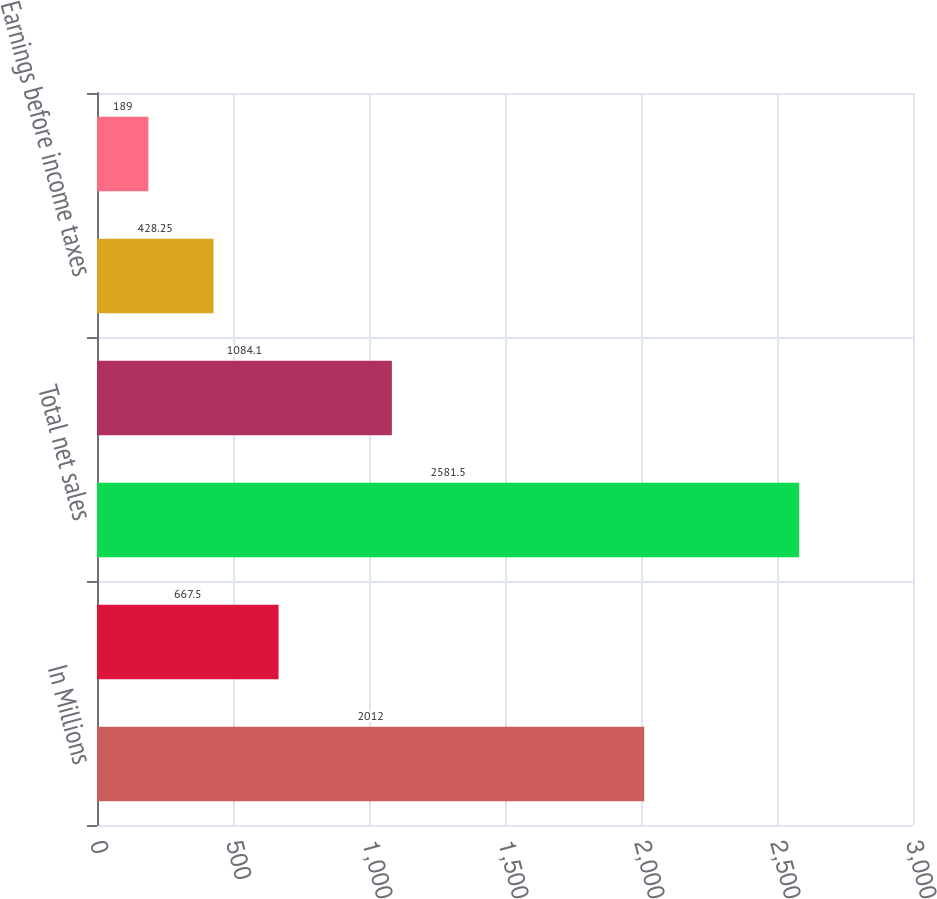Convert chart. <chart><loc_0><loc_0><loc_500><loc_500><bar_chart><fcel>In Millions<fcel>HDJ<fcel>Total net sales<fcel>Gross margin<fcel>Earnings before income taxes<fcel>Earnings after income taxes<nl><fcel>2012<fcel>667.5<fcel>2581.5<fcel>1084.1<fcel>428.25<fcel>189<nl></chart> 